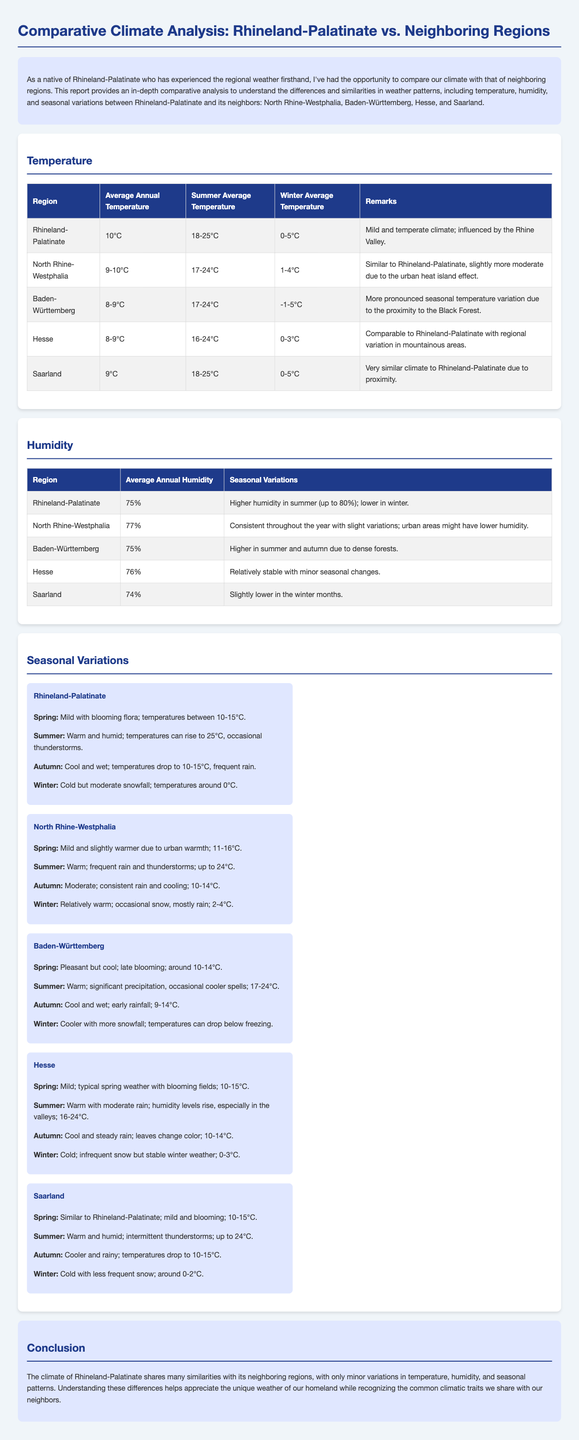What is the average annual temperature in Rhineland-Palatinate? The average annual temperature in Rhineland-Palatinate is listed in the document's temperature table.
Answer: 10°C What is the humidity level in Baden-Württemberg? The document provides average annual humidity levels for each region, including Baden-Württemberg.
Answer: 75% Which region has the highest average annual humidity? The humidity data reveals that North Rhine-Westphalia has the highest average annual humidity compared to others.
Answer: 77% What is the winter average temperature in Hesse? The document states the winter average temperature for Hesse in the temperature section.
Answer: 0-3°C How does the climate of Saarland compare to Rhineland-Palatinate? The remarks in the temperature section indicate that Saarland's climate is very similar to Rhineland-Palatinate.
Answer: Very similar What are the temperature ranges for summer in Rhineland-Palatinate and Saarland? By comparing the summer temperatures in the respective tables, the document allows us to see the temperature ranges.
Answer: 18-25°C What seasonal variation is observed in Rhineland-Palatinate during summer? The seasonal description for summer in Rhineland-Palatinate highlights specific weather phenomena.
Answer: Warm and humid How does the winter climate of Baden-Württemberg differ from Rhineland-Palatinate? The remarks on winter temperatures indicate differences in snowfall and temperatures across the regions.
Answer: Cooler with more snowfall What is the characteristic weather during spring in North Rhine-Westphalia? The seasonal description for spring provides details about typical weather conditions in North Rhine-Westphalia.
Answer: Mild and slightly warmer 